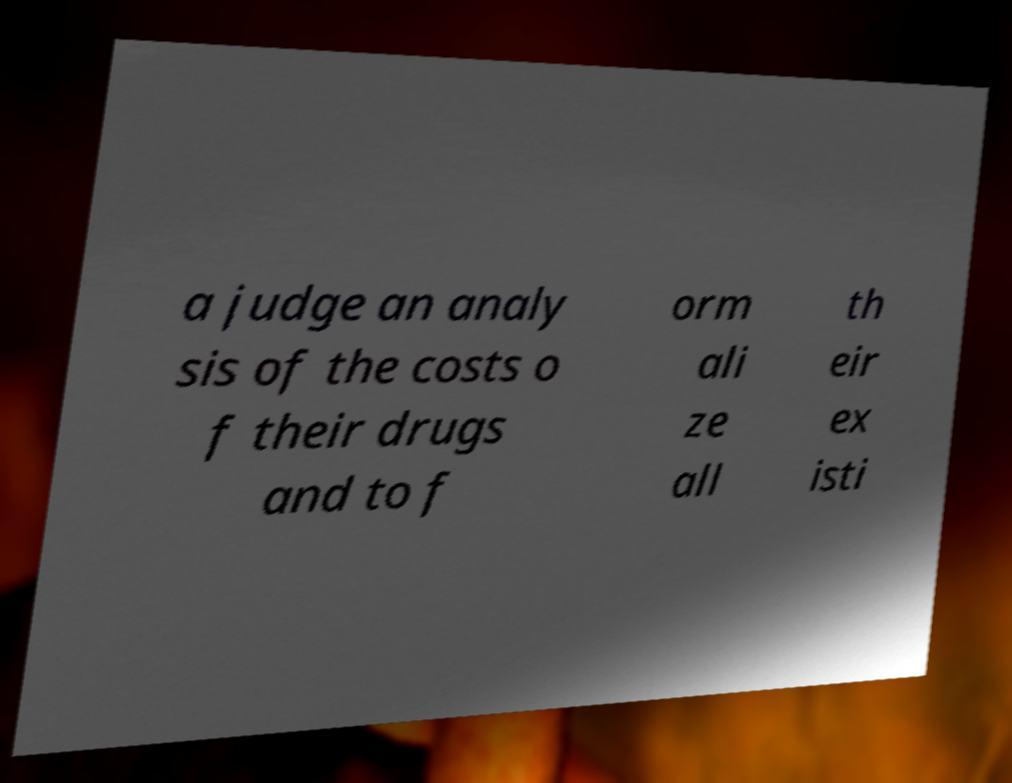Could you assist in decoding the text presented in this image and type it out clearly? a judge an analy sis of the costs o f their drugs and to f orm ali ze all th eir ex isti 